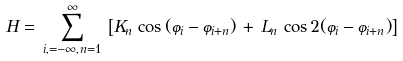<formula> <loc_0><loc_0><loc_500><loc_500>H = \, \sum _ { i , = - \infty , n = 1 } ^ { \infty } \, \left [ K _ { n } \, \cos { ( \varphi _ { i } - \varphi _ { i + n } ) } \, + \, L _ { n } \, \cos { 2 ( \varphi _ { i } - \varphi _ { i + n } ) } \right ]</formula> 